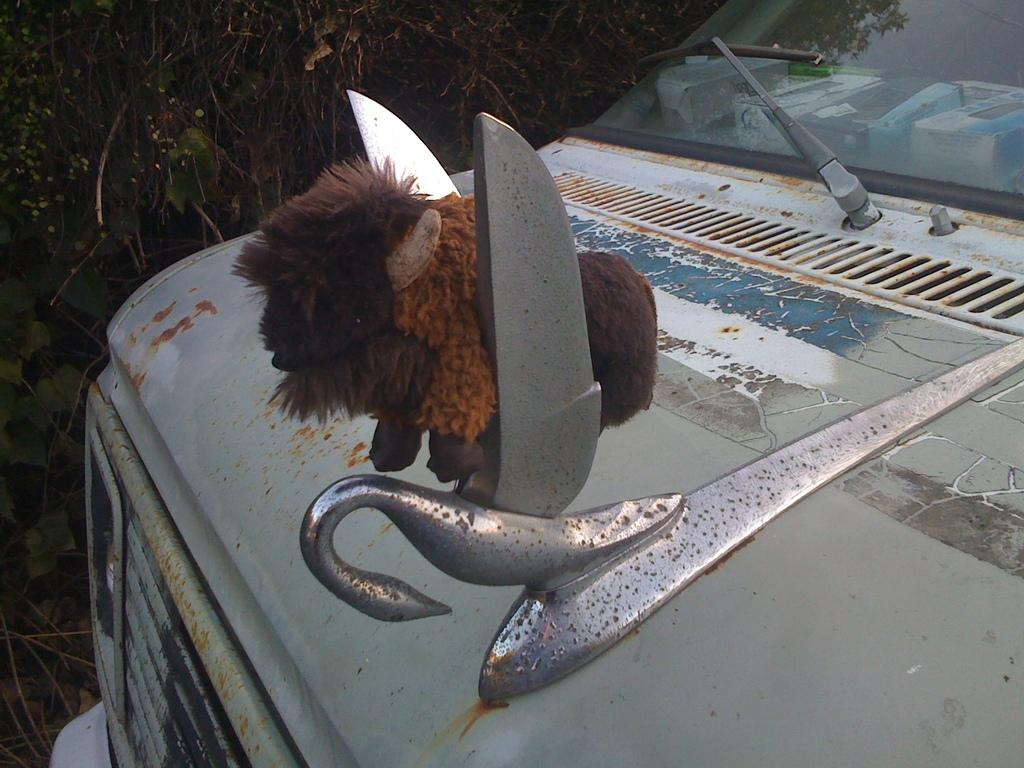What is the main subject of the image? The main subject of the image is a person (presumably the user) on a car. What can be seen in the background of the image? There are trees in the background of the image. What type of property is visible in the image? There is no specific property visible in the image; it only shows a person on a car and trees in the background. Can you see any cemetery in the image? There is no cemetery present in the image. 